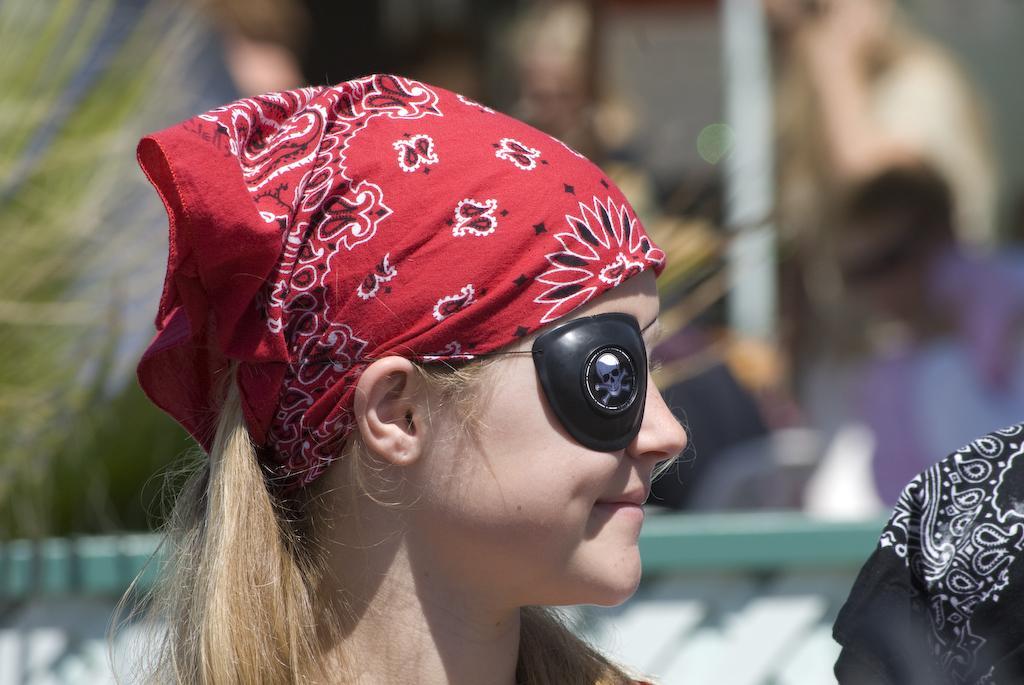Can you describe this image briefly? In this picture there is a kid wearing red color cloth on her head and an object to one of her eye is smiling and there are some other objects in the background. 